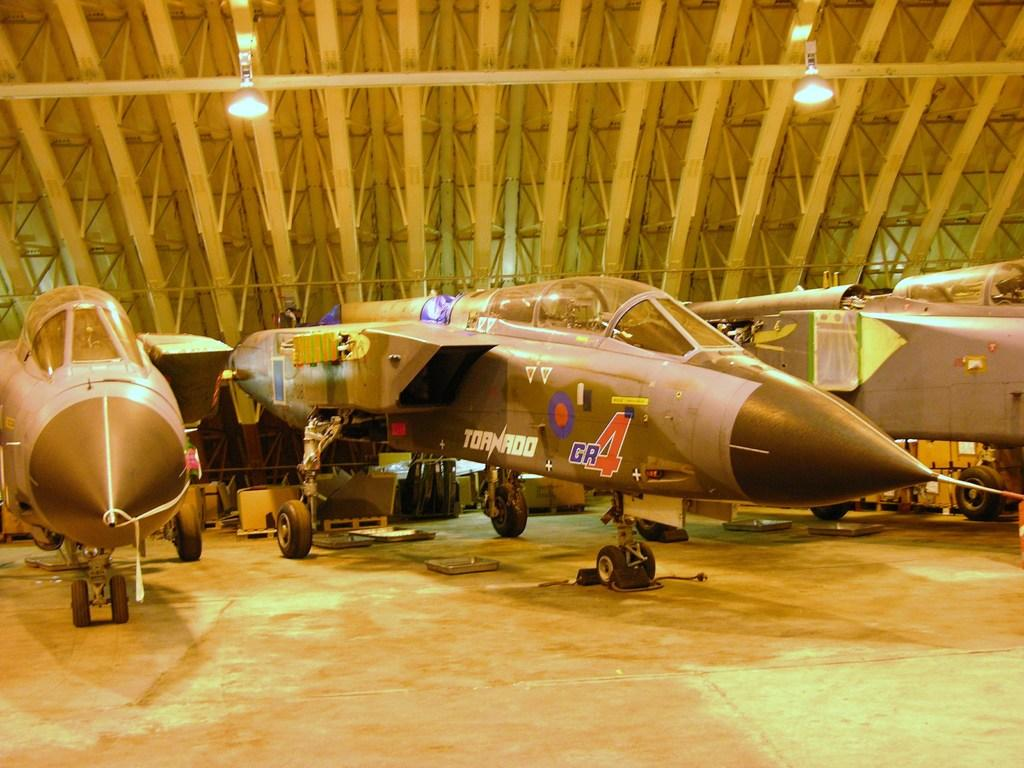<image>
Create a compact narrative representing the image presented. Black Tornado jet parked inside a closed area. 